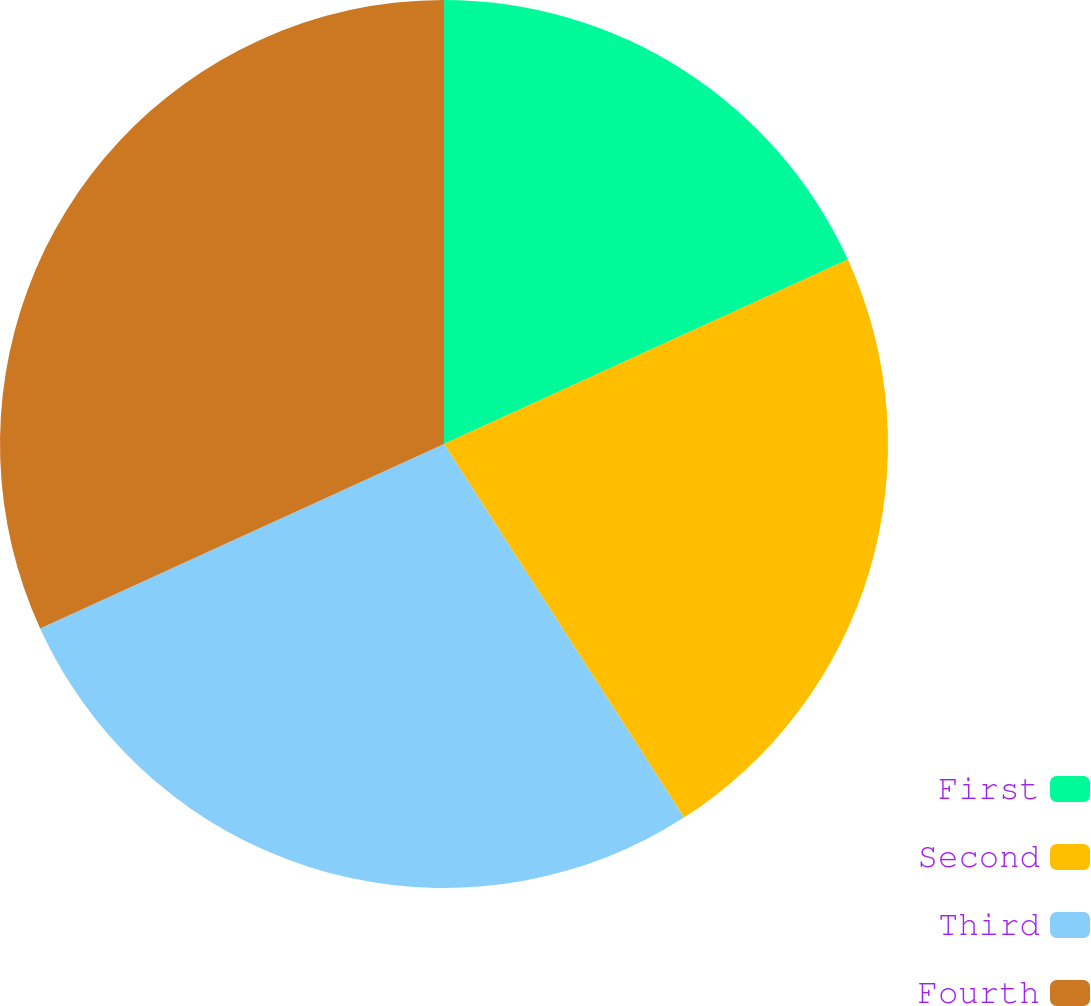Convert chart to OTSL. <chart><loc_0><loc_0><loc_500><loc_500><pie_chart><fcel>First<fcel>Second<fcel>Third<fcel>Fourth<nl><fcel>18.18%<fcel>22.73%<fcel>27.27%<fcel>31.82%<nl></chart> 